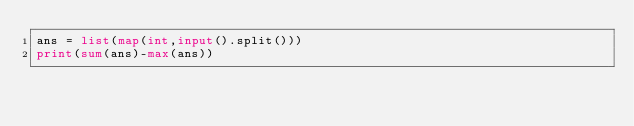<code> <loc_0><loc_0><loc_500><loc_500><_Python_>ans = list(map(int,input().split()))
print(sum(ans)-max(ans))</code> 